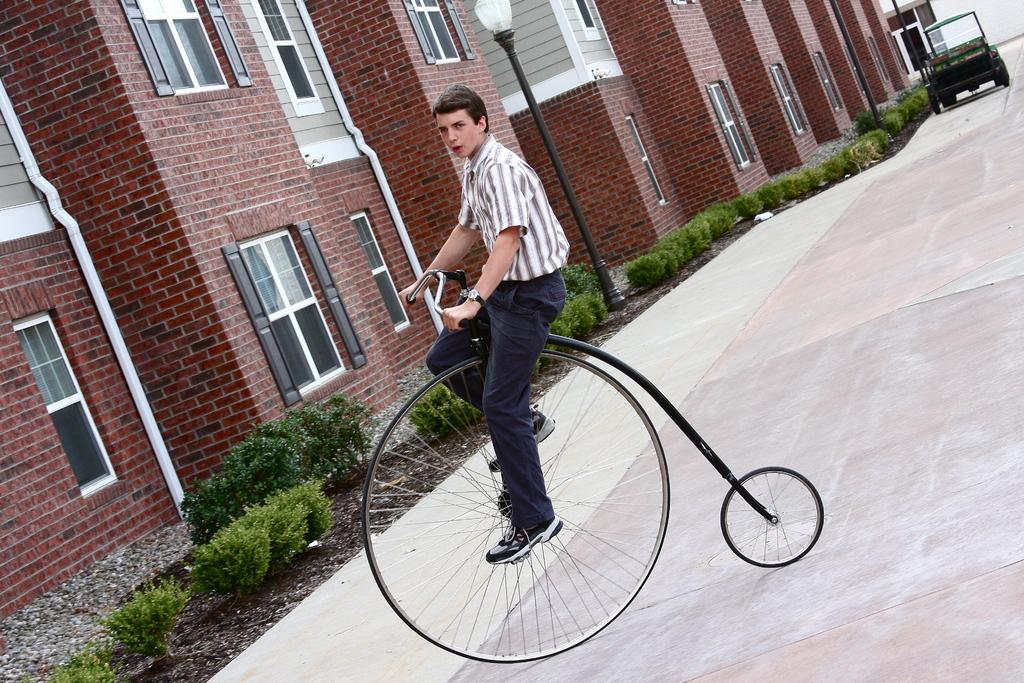What is the main subject of the image? The main subject of the image is a man. What is the man doing in the image? The man is riding a vehicle that looks like a bicycle. What can be seen in the background of the image? There are buildings, windows, plants, poles, and a light in the background of the image. Can you describe the other vehicle in the background? Unfortunately, the facts provided do not give a detailed description of the other vehicle. What is the man arguing about with the wall in the image? There is no wall present in the image, and therefore no argument can be observed. 